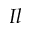Convert formula to latex. <formula><loc_0><loc_0><loc_500><loc_500>I l</formula> 